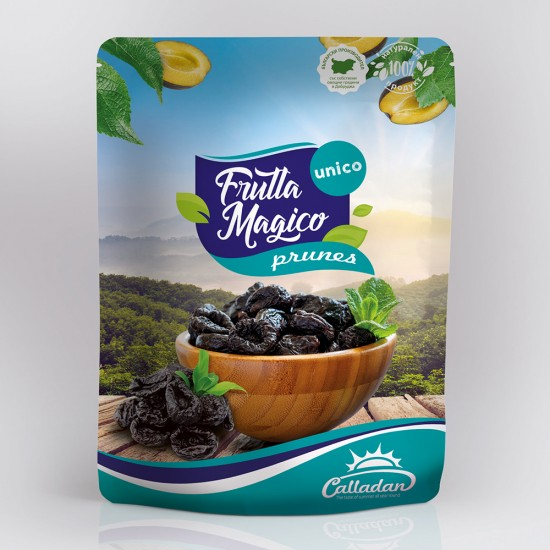Can you suggest any recipes or dishes where these flavored prunes could be used? Certainly! These lemon and mint-infused prunes can be a delightful addition to various dishes. For a start, they could be chopped and added to a fresh garden salad to introduce a sweet and tangy profile. Another excellent use would be in baking, perhaps in a lemon prune loaf or muffins, where their flavor complements the citrus notes. For a more savory application, blending them into a sauce for grilled chicken or pork could offer a lovely balance of flavors, enhancing the meat's natural tastes with a touch of sweetness and a hint of refreshing mint. 